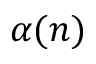<formula> <loc_0><loc_0><loc_500><loc_500>\alpha ( n )</formula> 